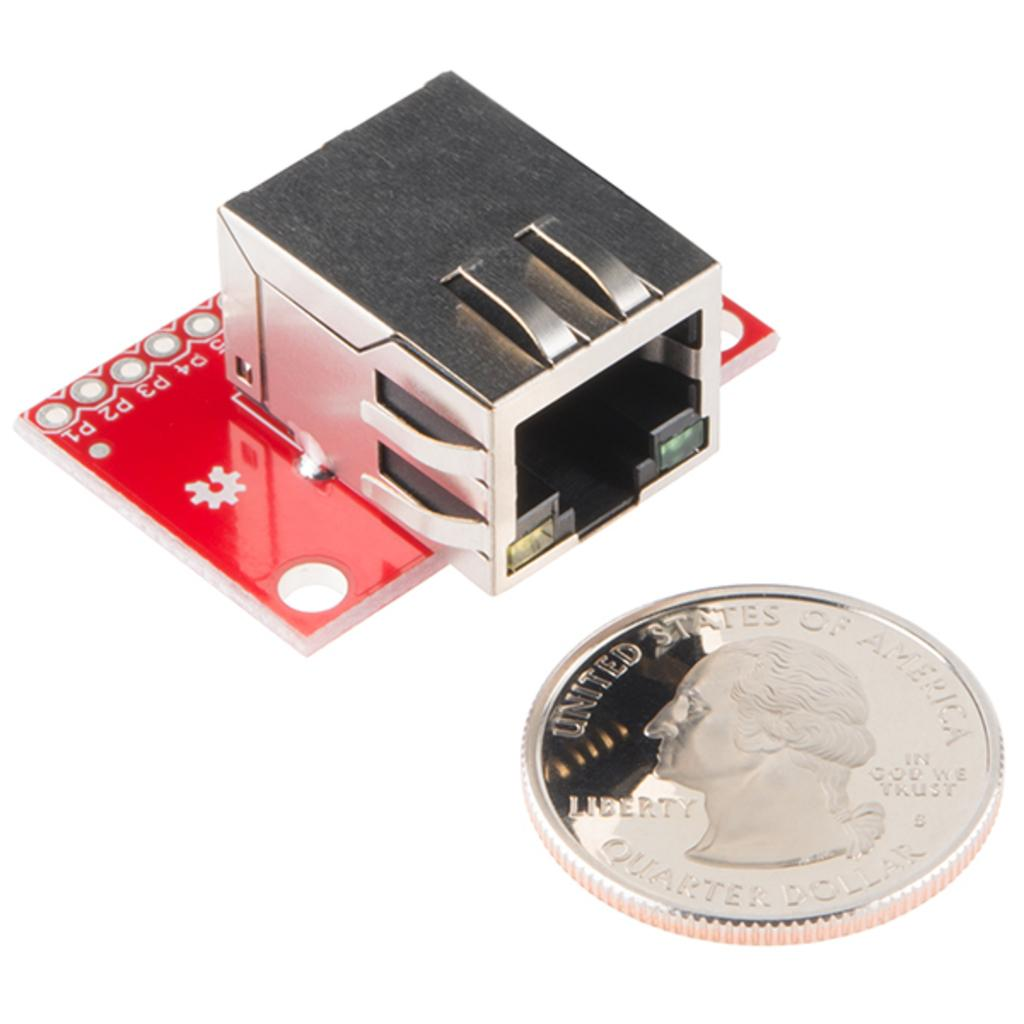<image>
Give a short and clear explanation of the subsequent image. A silver quarter dollar next to an ethernet connector. 